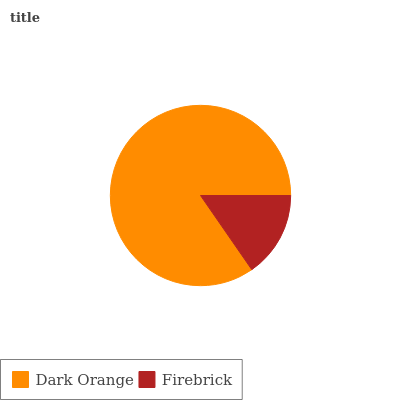Is Firebrick the minimum?
Answer yes or no. Yes. Is Dark Orange the maximum?
Answer yes or no. Yes. Is Firebrick the maximum?
Answer yes or no. No. Is Dark Orange greater than Firebrick?
Answer yes or no. Yes. Is Firebrick less than Dark Orange?
Answer yes or no. Yes. Is Firebrick greater than Dark Orange?
Answer yes or no. No. Is Dark Orange less than Firebrick?
Answer yes or no. No. Is Dark Orange the high median?
Answer yes or no. Yes. Is Firebrick the low median?
Answer yes or no. Yes. Is Firebrick the high median?
Answer yes or no. No. Is Dark Orange the low median?
Answer yes or no. No. 